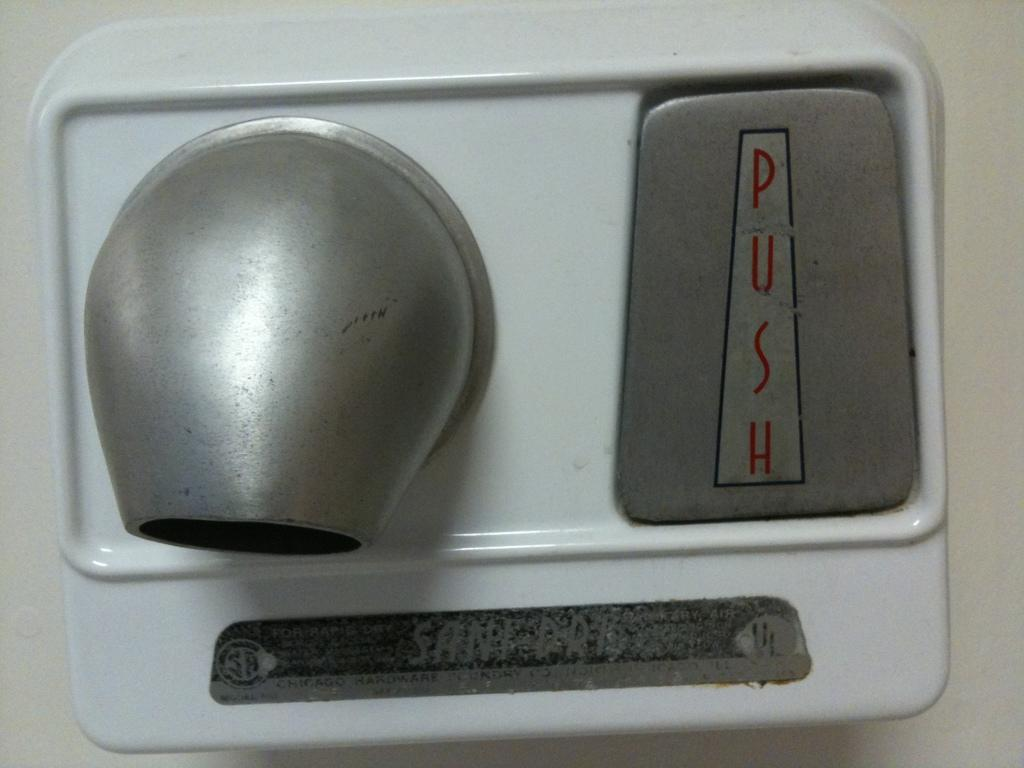<image>
Provide a brief description of the given image. A handryer sitting on a wall has a large button that says push. 